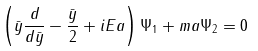<formula> <loc_0><loc_0><loc_500><loc_500>\left ( \bar { y } \frac { d } { d \bar { y } } - \frac { \bar { y } } { 2 } + i E a \right ) \Psi _ { 1 } + m a \Psi _ { 2 } = 0</formula> 